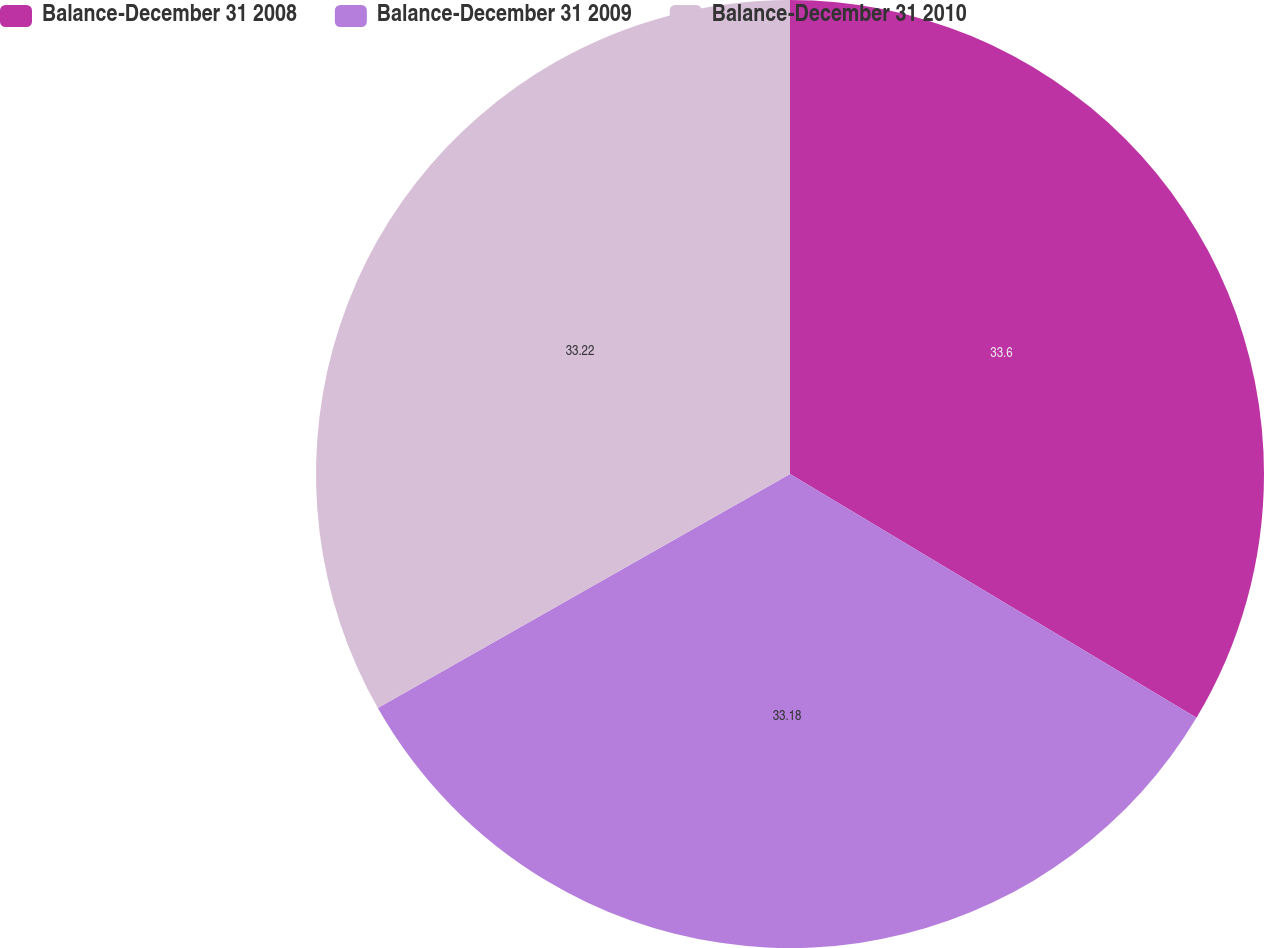<chart> <loc_0><loc_0><loc_500><loc_500><pie_chart><fcel>Balance-December 31 2008<fcel>Balance-December 31 2009<fcel>Balance-December 31 2010<nl><fcel>33.6%<fcel>33.18%<fcel>33.22%<nl></chart> 